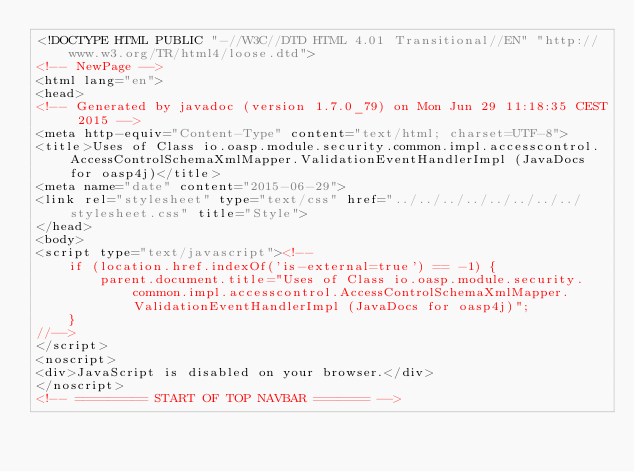Convert code to text. <code><loc_0><loc_0><loc_500><loc_500><_HTML_><!DOCTYPE HTML PUBLIC "-//W3C//DTD HTML 4.01 Transitional//EN" "http://www.w3.org/TR/html4/loose.dtd">
<!-- NewPage -->
<html lang="en">
<head>
<!-- Generated by javadoc (version 1.7.0_79) on Mon Jun 29 11:18:35 CEST 2015 -->
<meta http-equiv="Content-Type" content="text/html; charset=UTF-8">
<title>Uses of Class io.oasp.module.security.common.impl.accesscontrol.AccessControlSchemaXmlMapper.ValidationEventHandlerImpl (JavaDocs for oasp4j)</title>
<meta name="date" content="2015-06-29">
<link rel="stylesheet" type="text/css" href="../../../../../../../../stylesheet.css" title="Style">
</head>
<body>
<script type="text/javascript"><!--
    if (location.href.indexOf('is-external=true') == -1) {
        parent.document.title="Uses of Class io.oasp.module.security.common.impl.accesscontrol.AccessControlSchemaXmlMapper.ValidationEventHandlerImpl (JavaDocs for oasp4j)";
    }
//-->
</script>
<noscript>
<div>JavaScript is disabled on your browser.</div>
</noscript>
<!-- ========= START OF TOP NAVBAR ======= --></code> 